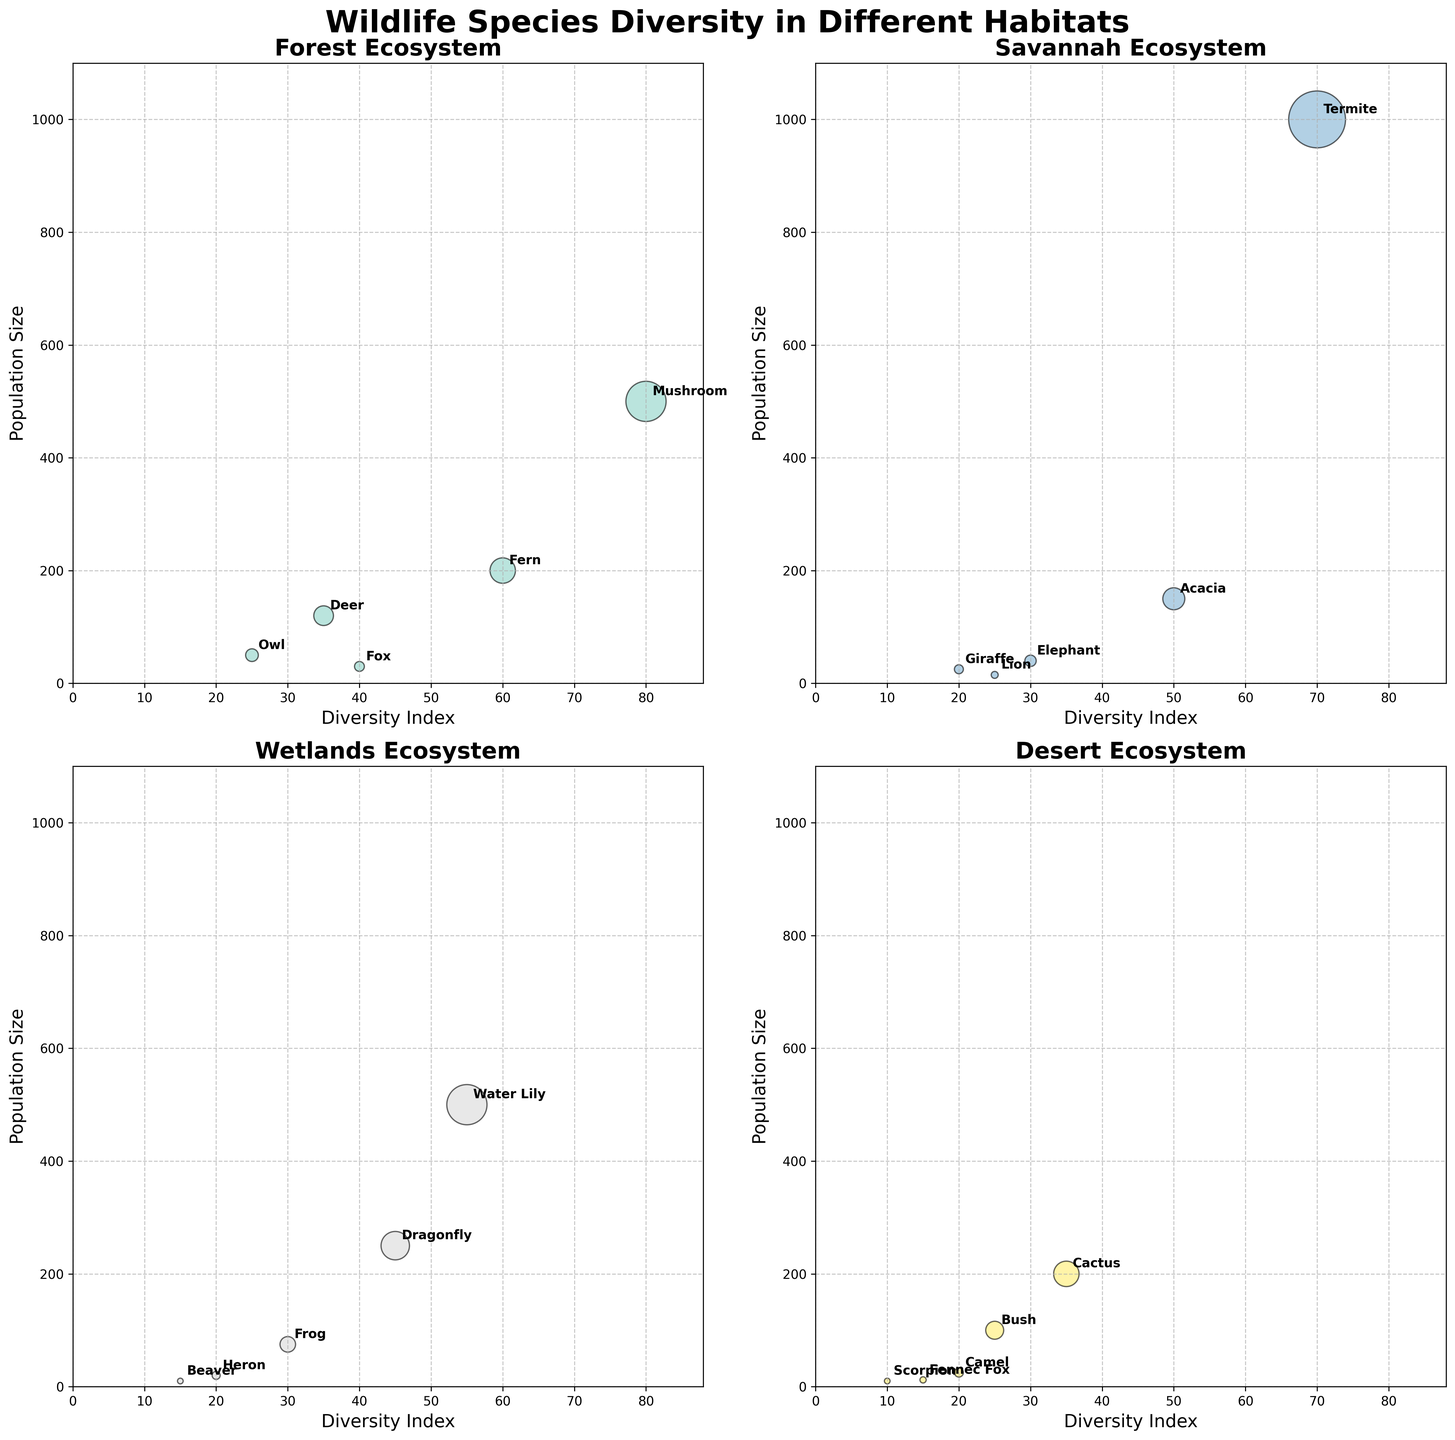Which habitat has the highest maximum population size for any species? The y-axis corresponds to the population size and looking at the scatter plots, the Wetlands have the dot at the highest point, representing a population size of 500 (Water Lily).
Answer: Wetlands What is the species with the highest Diversity Index in the Forest habitat? In the Forest subplot, the x-axis represents the Diversity Index. The species with the highest Diversity Index is the Mushroom with a Diversity Index of 80.
Answer: Mushroom How does the population size of the Deer in the Forest compare to the population size of the Lion in the Savannah? In the Forest subplot, the Deer has a population size of 120. In the Savannah subplot, the Lion has a population size of 15. Deer has a higher population size than Lion.
Answer: Deer has a higher population size than Lion In which habitat does the species with the lowest Diversity Index reside? The y-axis across all subplots shows the Diversity Index. The Desert habitat has the lowest point on the x-axis at Diversity Index 10 for the Scorpion.
Answer: Desert What is the median Diversity Index of species in the Wetlands? The Diversity Index values in Wetlands are 30, 20, 15, 55, and 45. Arranging these values in ascending order: 15, 20, 30, 45, 55, the median value is the middle one, which is 30.
Answer: 30 What species in the Savannah has both a high population size and a high Diversity Index? In the Savannah subplot, the Acacia has a high Diversity Index (50) and a high population size (150).
Answer: Acacia Which habitat shows the highest diversity among plant species? In the Forest subplot, Fern has a Diversity Index of 60 and Mushroom has 80; in the Savannah, Acacia has 50; in the Wetlands, Water Lily has 55. The Forest has both highest and diverse Diversity Index values for plants.
Answer: Forest Compare the population sizes of the Termite in the Savannah and the Mushroom in the Forest. Which is larger? Looking at the scatter plots for these specific species, Termite has a population size of 1000, and Mushroom in the Forest has a population size of 500. Termite has a larger population size.
Answer: Termite is larger Which habitat has the smallest total population size for its species? Summing up the population sizes: Forest = 120+30+50+200+500=900, Savannah = 15+40+25+150+1000=1230, Wetlands = 75+20+10+500+250=855, Desert = 10+25+12+200+100=347. Desert has 347, which is the smallest.
Answer: Desert 